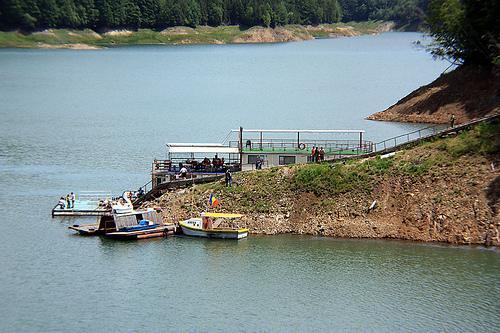People standing on something solid furthest into and above water stand on what?
Choose the right answer from the provided options to respond to the question.
Options: Plane, wharf, pier, ship. Pier. 